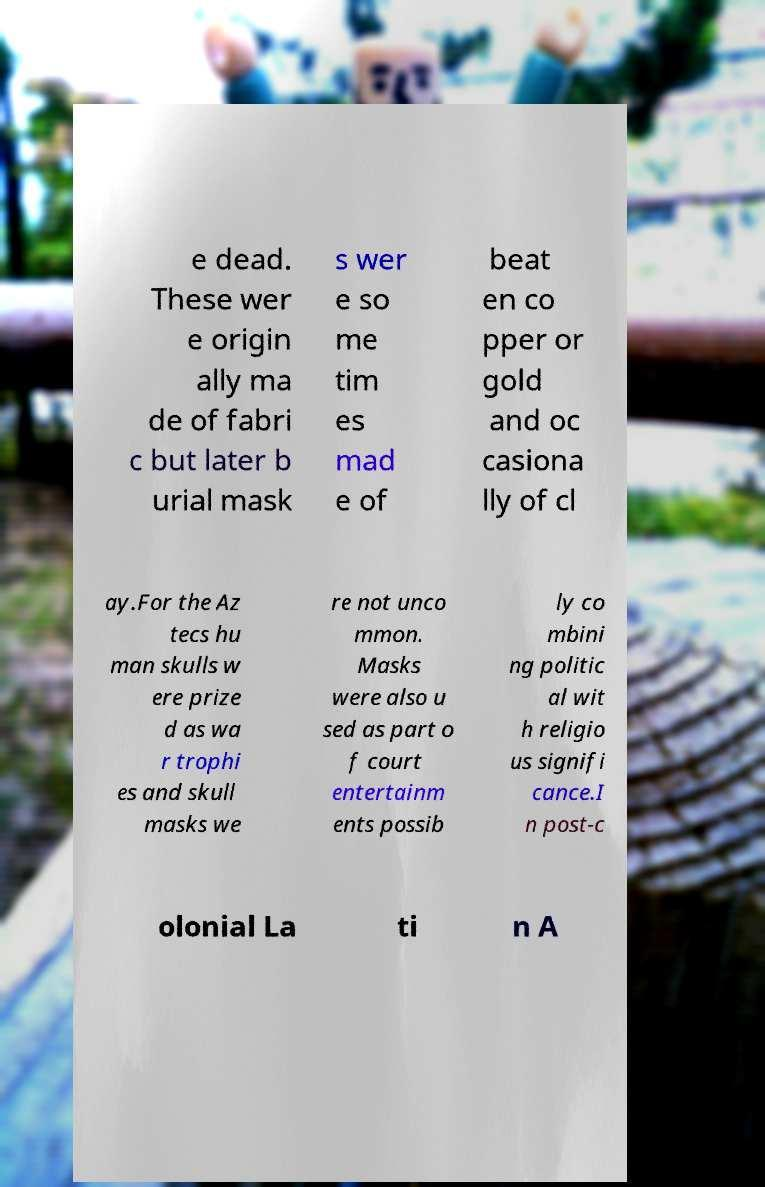I need the written content from this picture converted into text. Can you do that? e dead. These wer e origin ally ma de of fabri c but later b urial mask s wer e so me tim es mad e of beat en co pper or gold and oc casiona lly of cl ay.For the Az tecs hu man skulls w ere prize d as wa r trophi es and skull masks we re not unco mmon. Masks were also u sed as part o f court entertainm ents possib ly co mbini ng politic al wit h religio us signifi cance.I n post-c olonial La ti n A 